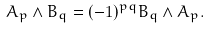Convert formula to latex. <formula><loc_0><loc_0><loc_500><loc_500>A _ { p } \wedge B _ { q } = ( - 1 ) ^ { p q } B _ { q } \wedge A _ { p } .</formula> 